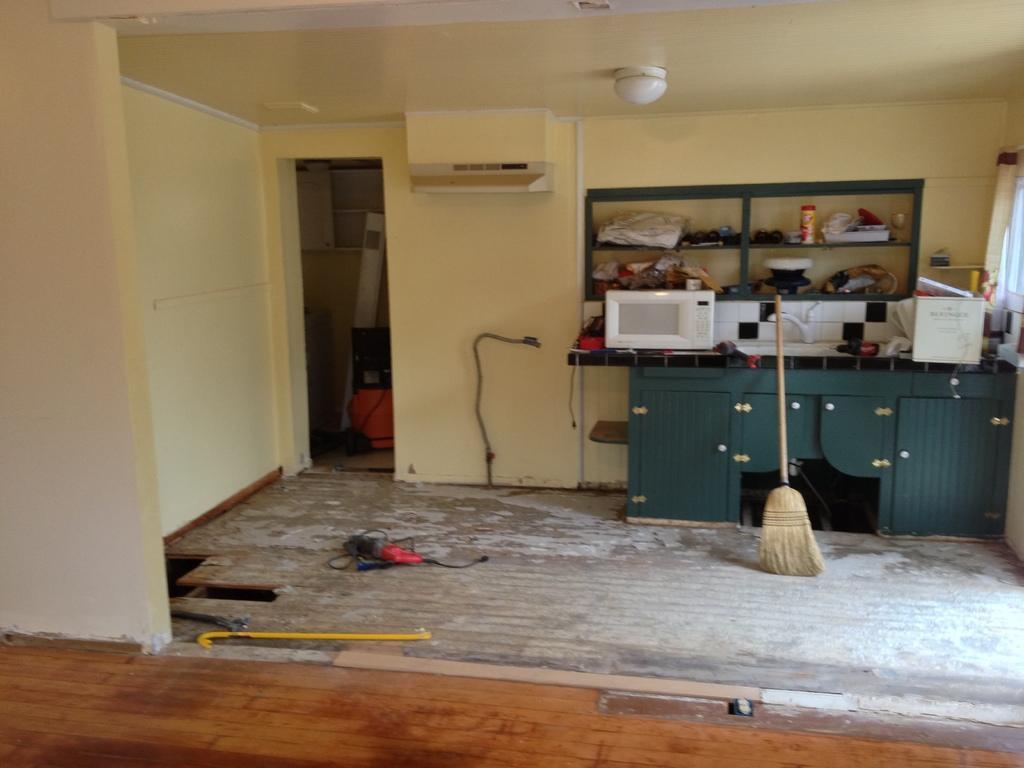In one or two sentences, can you explain what this image depicts? In this image in the center there is a broom and there is a table which is green in colour, on the table there is a microwave oven and there is an object which is white in colour. On the wall there is a shelf and in the Shelf there are clothes, there is a bottle and there is an object which is black in colour. On the left side of the wall there is a wire and on the floor there is an object which is red and black in colour. On the right side there is a curtain which is white in colour. On the top there is a light. 